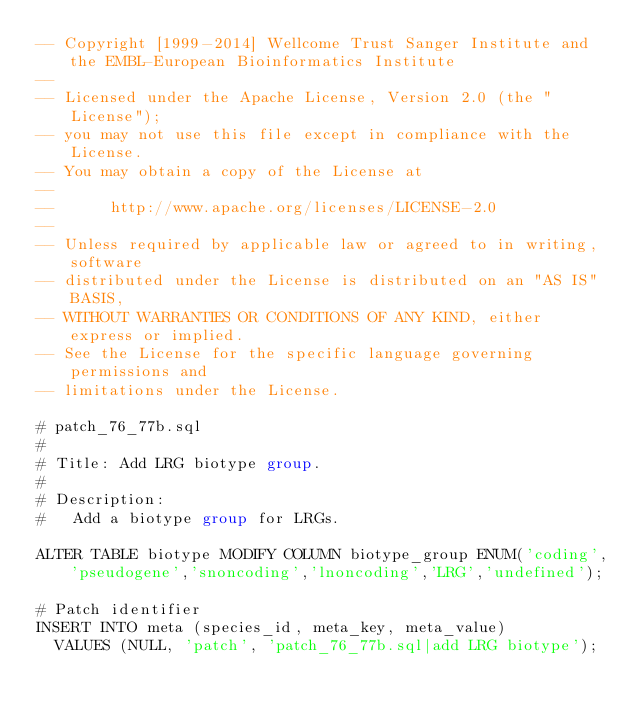<code> <loc_0><loc_0><loc_500><loc_500><_SQL_>-- Copyright [1999-2014] Wellcome Trust Sanger Institute and the EMBL-European Bioinformatics Institute
-- 
-- Licensed under the Apache License, Version 2.0 (the "License");
-- you may not use this file except in compliance with the License.
-- You may obtain a copy of the License at
-- 
--      http://www.apache.org/licenses/LICENSE-2.0
-- 
-- Unless required by applicable law or agreed to in writing, software
-- distributed under the License is distributed on an "AS IS" BASIS,
-- WITHOUT WARRANTIES OR CONDITIONS OF ANY KIND, either express or implied.
-- See the License for the specific language governing permissions and
-- limitations under the License.

# patch_76_77b.sql
#
# Title: Add LRG biotype group.
#
# Description:
#   Add a biotype group for LRGs.

ALTER TABLE biotype MODIFY COLUMN biotype_group ENUM('coding','pseudogene','snoncoding','lnoncoding','LRG','undefined');

# Patch identifier
INSERT INTO meta (species_id, meta_key, meta_value)
  VALUES (NULL, 'patch', 'patch_76_77b.sql|add LRG biotype');
</code> 